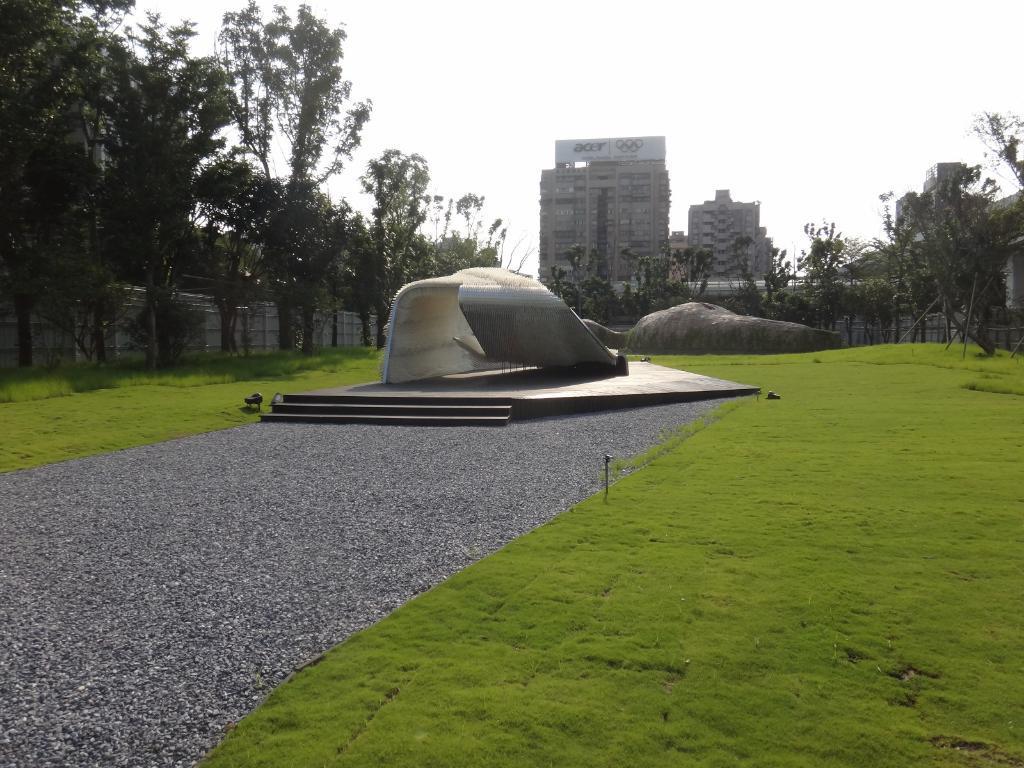Describe this image in one or two sentences. In the picture we can see the grass surface in the middle of it, we can see a path with a sculpture and around the grass surface, we can see the trees and we can see a building with some floors and behind it we can see the sky. 